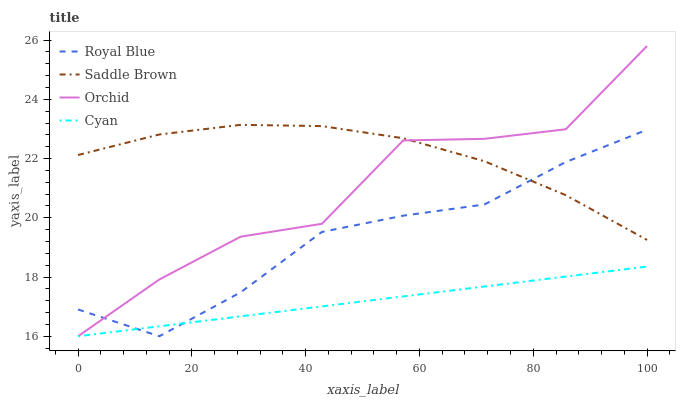Does Cyan have the minimum area under the curve?
Answer yes or no. Yes. Does Saddle Brown have the maximum area under the curve?
Answer yes or no. Yes. Does Saddle Brown have the minimum area under the curve?
Answer yes or no. No. Does Cyan have the maximum area under the curve?
Answer yes or no. No. Is Cyan the smoothest?
Answer yes or no. Yes. Is Orchid the roughest?
Answer yes or no. Yes. Is Saddle Brown the smoothest?
Answer yes or no. No. Is Saddle Brown the roughest?
Answer yes or no. No. Does Royal Blue have the lowest value?
Answer yes or no. Yes. Does Saddle Brown have the lowest value?
Answer yes or no. No. Does Orchid have the highest value?
Answer yes or no. Yes. Does Saddle Brown have the highest value?
Answer yes or no. No. Is Cyan less than Saddle Brown?
Answer yes or no. Yes. Is Saddle Brown greater than Cyan?
Answer yes or no. Yes. Does Cyan intersect Royal Blue?
Answer yes or no. Yes. Is Cyan less than Royal Blue?
Answer yes or no. No. Is Cyan greater than Royal Blue?
Answer yes or no. No. Does Cyan intersect Saddle Brown?
Answer yes or no. No. 